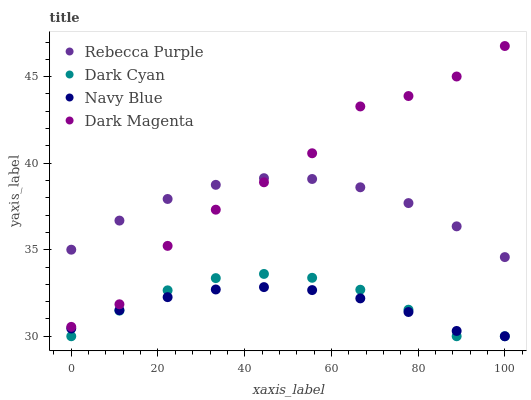Does Navy Blue have the minimum area under the curve?
Answer yes or no. Yes. Does Dark Magenta have the maximum area under the curve?
Answer yes or no. Yes. Does Rebecca Purple have the minimum area under the curve?
Answer yes or no. No. Does Rebecca Purple have the maximum area under the curve?
Answer yes or no. No. Is Navy Blue the smoothest?
Answer yes or no. Yes. Is Dark Magenta the roughest?
Answer yes or no. Yes. Is Rebecca Purple the smoothest?
Answer yes or no. No. Is Rebecca Purple the roughest?
Answer yes or no. No. Does Dark Cyan have the lowest value?
Answer yes or no. Yes. Does Rebecca Purple have the lowest value?
Answer yes or no. No. Does Dark Magenta have the highest value?
Answer yes or no. Yes. Does Rebecca Purple have the highest value?
Answer yes or no. No. Is Navy Blue less than Rebecca Purple?
Answer yes or no. Yes. Is Dark Magenta greater than Dark Cyan?
Answer yes or no. Yes. Does Dark Magenta intersect Rebecca Purple?
Answer yes or no. Yes. Is Dark Magenta less than Rebecca Purple?
Answer yes or no. No. Is Dark Magenta greater than Rebecca Purple?
Answer yes or no. No. Does Navy Blue intersect Rebecca Purple?
Answer yes or no. No. 